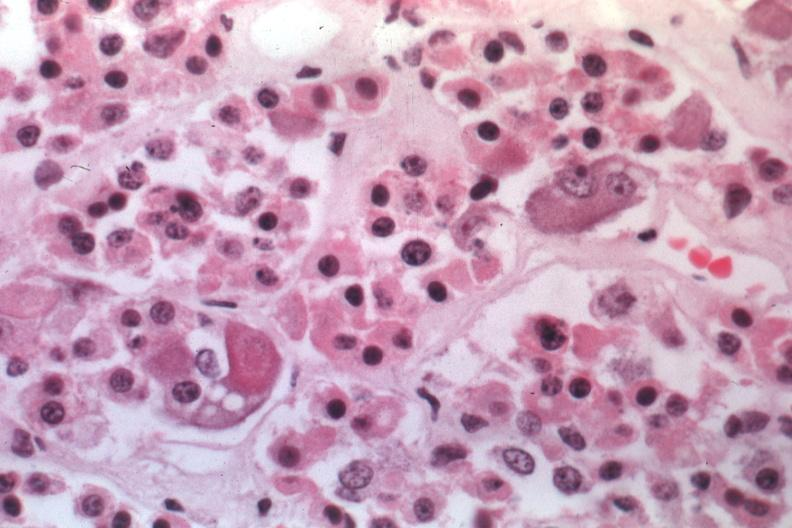s liver present?
Answer the question using a single word or phrase. No 